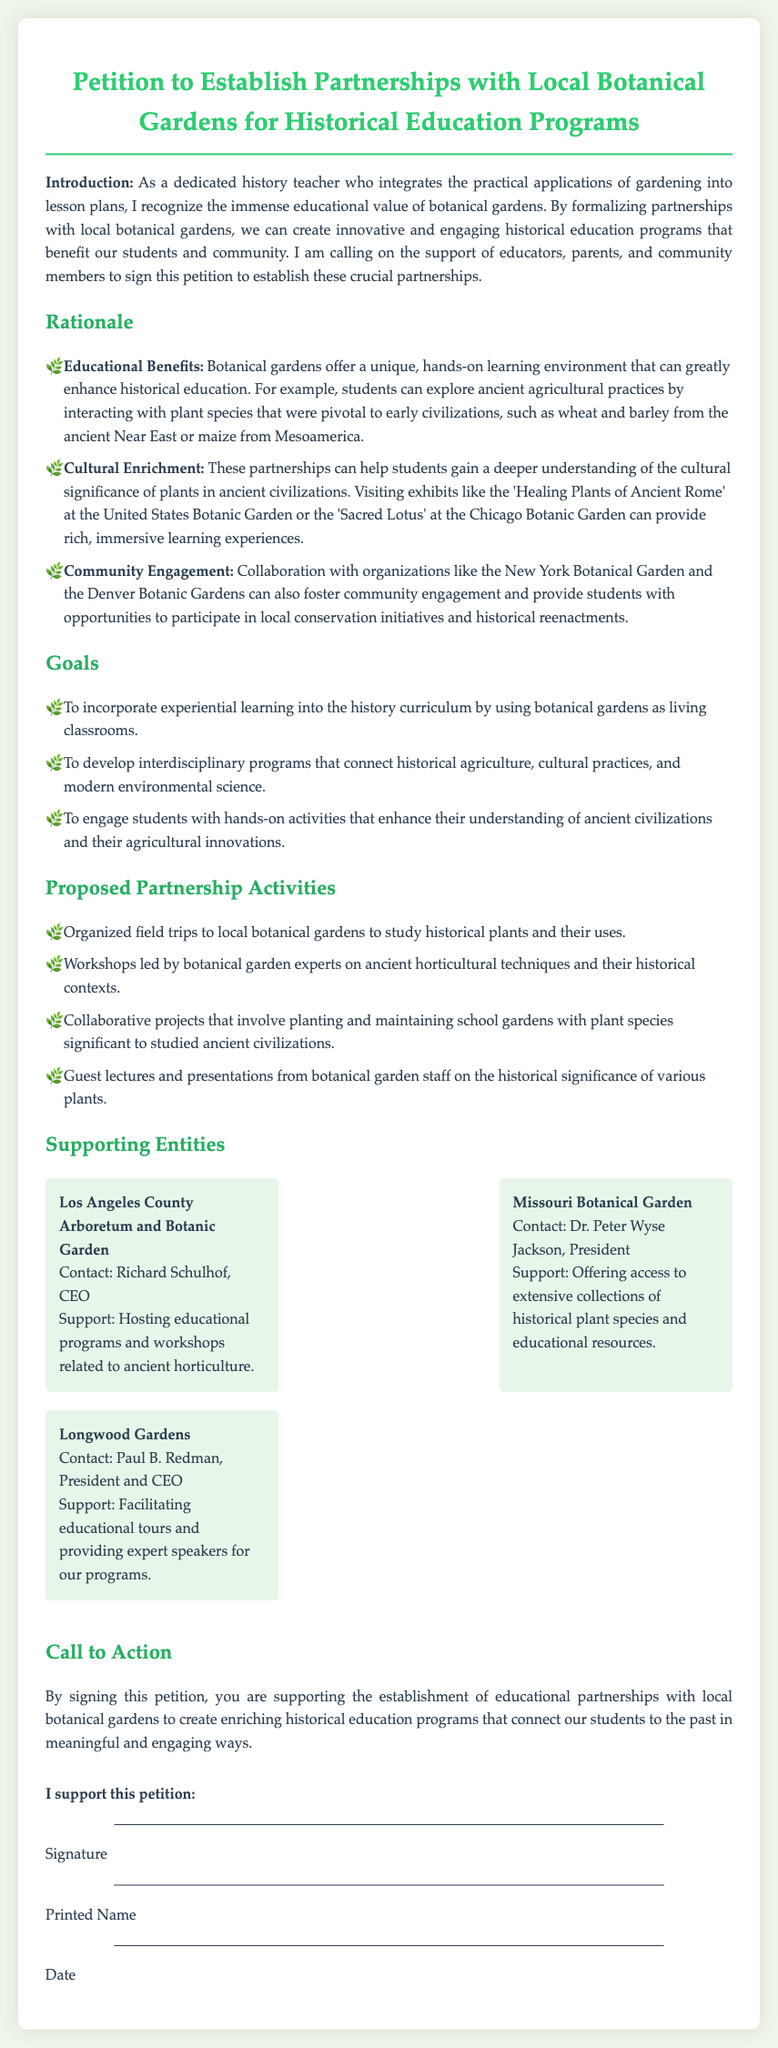What is the title of the petition? The title is explicitly stated at the top of the document, introducing the purpose of the petition.
Answer: Petition to Establish Partnerships with Local Botanical Gardens for Historical Education Programs Who is the intended audience for this petition? The document specifies the target audience as educators, parents, and community members.
Answer: Educators, parents, and community members What type of learning environment do botanical gardens provide? Descriptions in the document emphasize the hands-on aspect of learning facilitated by botanical gardens.
Answer: Hands-on learning environment How many supporting entities are mentioned? The document lists three specific botanical gardens as supporting entities.
Answer: Three Who is the contact person for the Los Angeles County Arboretum and Botanic Garden? The name of the CEO is provided under the supporting entities section.
Answer: Richard Schulhof What is one of the proposed activities in the partnership? The document outlines specific activities that would be part of the partnership initiative.
Answer: Organized field trips What are the educational benefits of botanical gardens according to the petition? The rationale includes specific advantages that botanical gardens provide in education.
Answer: Unique, hands-on learning environment What is the main call to action in the petition? The final section encourages readers to take a specific supportive action regarding the petition.
Answer: Supporting the establishment of educational partnerships 